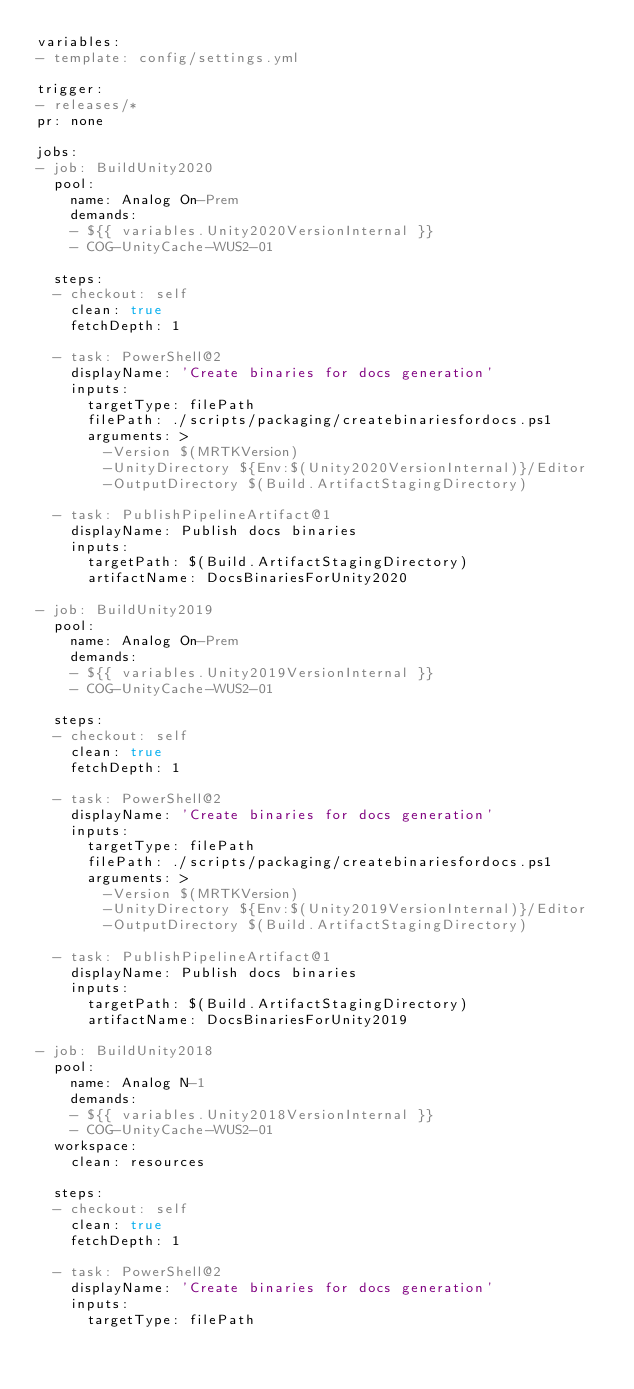<code> <loc_0><loc_0><loc_500><loc_500><_YAML_>variables:
- template: config/settings.yml

trigger:
- releases/*
pr: none

jobs:
- job: BuildUnity2020
  pool:
    name: Analog On-Prem
    demands:
    - ${{ variables.Unity2020VersionInternal }}
    - COG-UnityCache-WUS2-01

  steps:
  - checkout: self
    clean: true
    fetchDepth: 1

  - task: PowerShell@2
    displayName: 'Create binaries for docs generation'
    inputs:
      targetType: filePath
      filePath: ./scripts/packaging/createbinariesfordocs.ps1
      arguments: >
        -Version $(MRTKVersion)
        -UnityDirectory ${Env:$(Unity2020VersionInternal)}/Editor
        -OutputDirectory $(Build.ArtifactStagingDirectory)

  - task: PublishPipelineArtifact@1
    displayName: Publish docs binaries
    inputs:
      targetPath: $(Build.ArtifactStagingDirectory)
      artifactName: DocsBinariesForUnity2020

- job: BuildUnity2019
  pool:
    name: Analog On-Prem
    demands:
    - ${{ variables.Unity2019VersionInternal }}
    - COG-UnityCache-WUS2-01

  steps:
  - checkout: self
    clean: true
    fetchDepth: 1

  - task: PowerShell@2
    displayName: 'Create binaries for docs generation'
    inputs:
      targetType: filePath
      filePath: ./scripts/packaging/createbinariesfordocs.ps1
      arguments: >
        -Version $(MRTKVersion)
        -UnityDirectory ${Env:$(Unity2019VersionInternal)}/Editor
        -OutputDirectory $(Build.ArtifactStagingDirectory)

  - task: PublishPipelineArtifact@1
    displayName: Publish docs binaries
    inputs:
      targetPath: $(Build.ArtifactStagingDirectory)
      artifactName: DocsBinariesForUnity2019

- job: BuildUnity2018
  pool:
    name: Analog N-1
    demands:
    - ${{ variables.Unity2018VersionInternal }}
    - COG-UnityCache-WUS2-01
  workspace:
    clean: resources

  steps:
  - checkout: self
    clean: true
    fetchDepth: 1

  - task: PowerShell@2
    displayName: 'Create binaries for docs generation'
    inputs:
      targetType: filePath</code> 